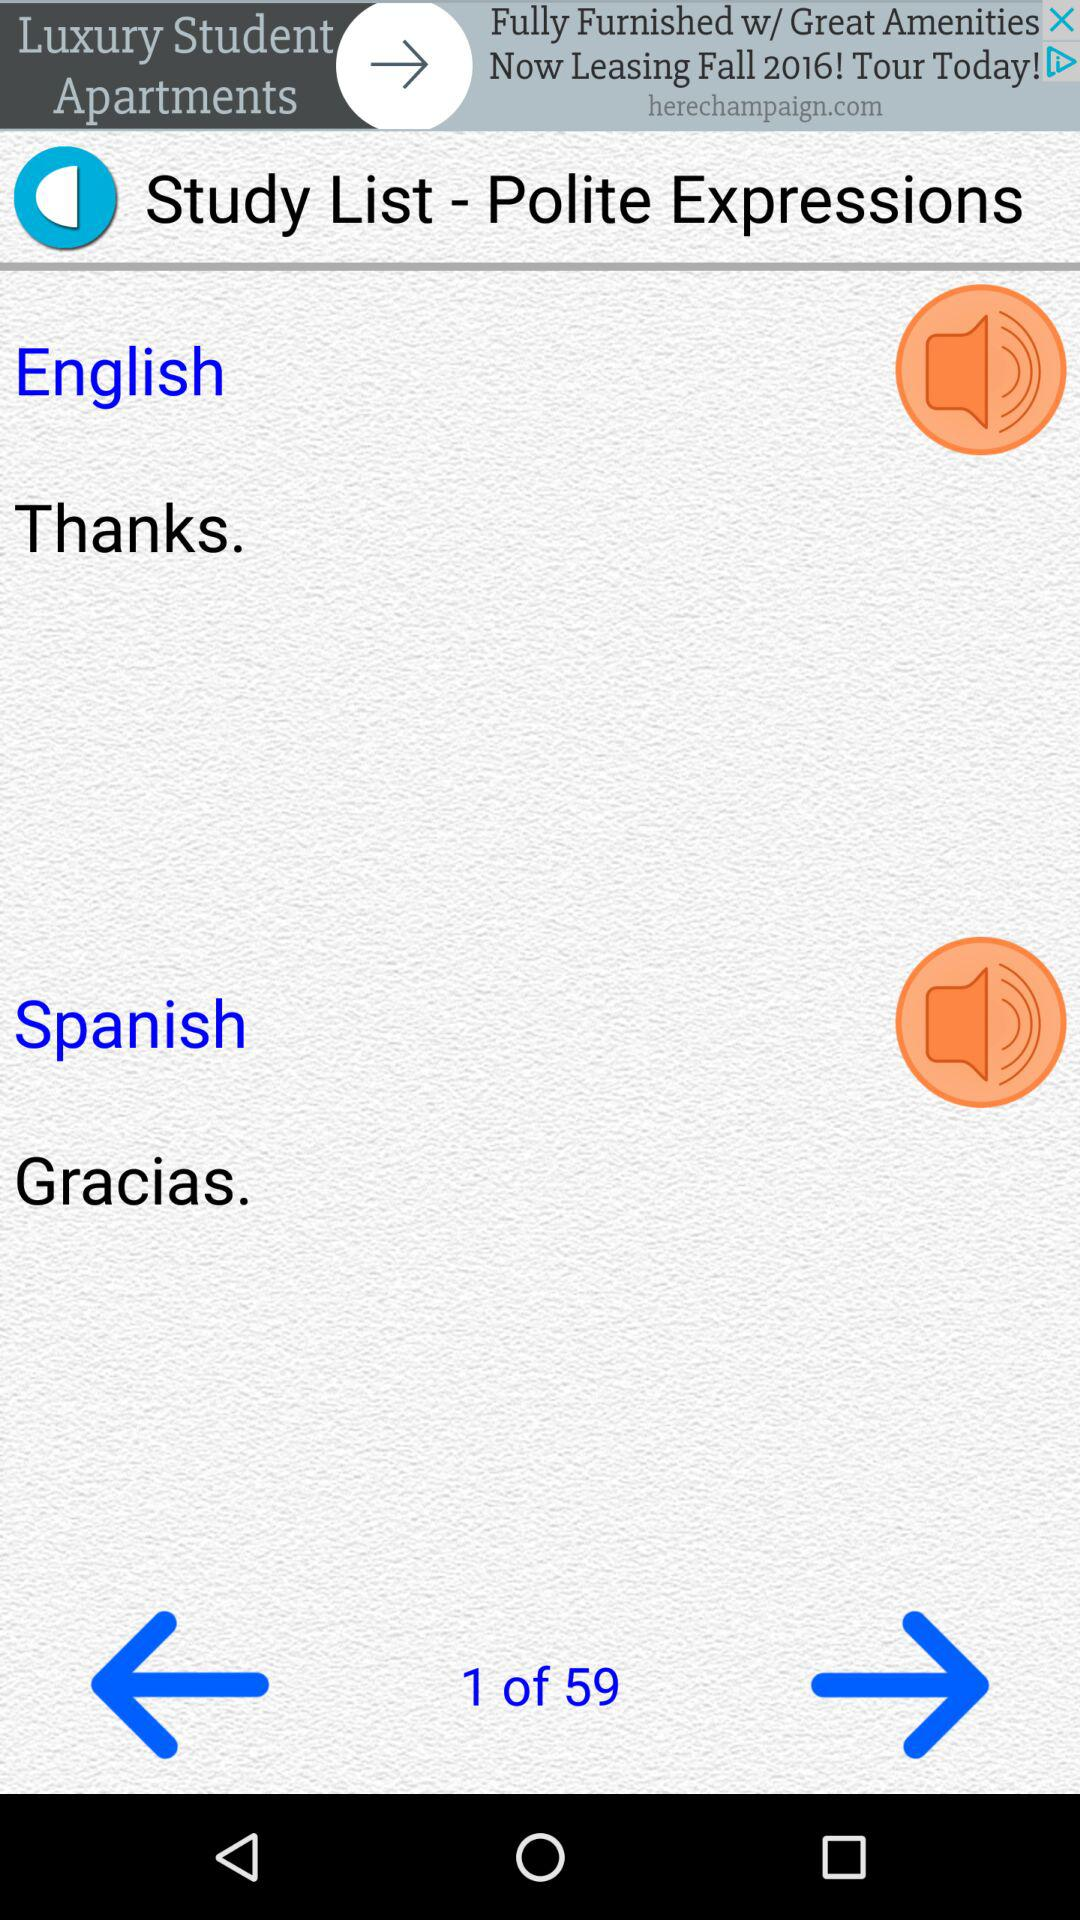What is the text entered in the English language? The text entered is "Thanks". 